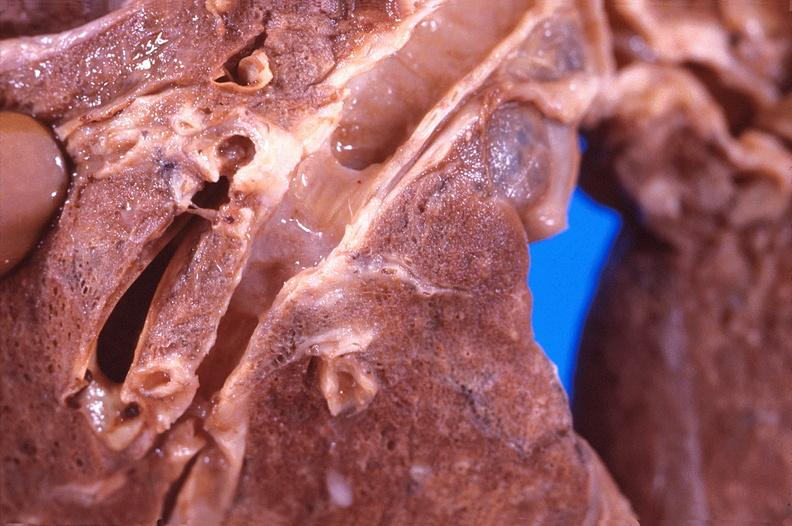what is present?
Answer the question using a single word or phrase. Respiratory 